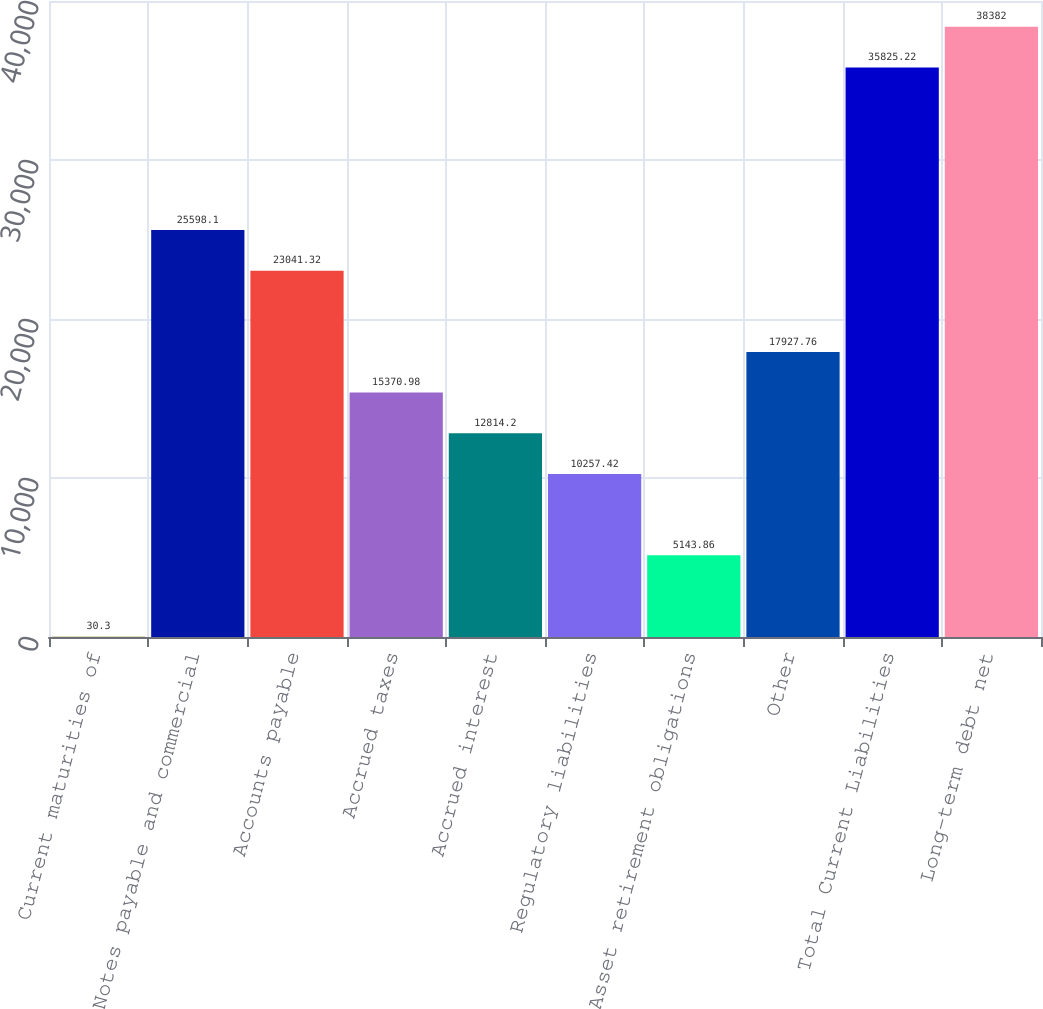Convert chart to OTSL. <chart><loc_0><loc_0><loc_500><loc_500><bar_chart><fcel>Current maturities of<fcel>Notes payable and commercial<fcel>Accounts payable<fcel>Accrued taxes<fcel>Accrued interest<fcel>Regulatory liabilities<fcel>Asset retirement obligations<fcel>Other<fcel>Total Current Liabilities<fcel>Long-term debt net<nl><fcel>30.3<fcel>25598.1<fcel>23041.3<fcel>15371<fcel>12814.2<fcel>10257.4<fcel>5143.86<fcel>17927.8<fcel>35825.2<fcel>38382<nl></chart> 